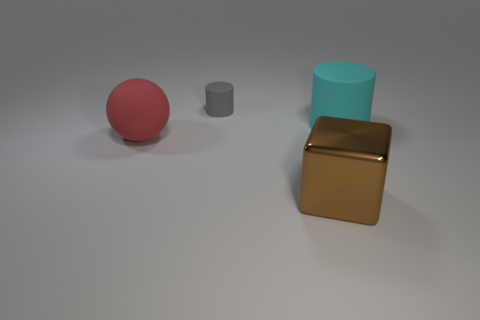Is there anything else that is the same material as the gray object?
Provide a short and direct response. Yes. What number of matte things are there?
Keep it short and to the point. 3. Does the tiny cylinder have the same color as the big metal thing?
Your answer should be very brief. No. There is a thing that is on the right side of the large red object and to the left of the large brown shiny thing; what color is it?
Keep it short and to the point. Gray. There is a tiny gray matte cylinder; are there any brown metal objects behind it?
Your answer should be very brief. No. What number of big cyan cylinders are behind the big rubber thing that is right of the tiny gray cylinder?
Give a very brief answer. 0. There is a sphere that is the same material as the cyan thing; what size is it?
Your answer should be very brief. Large. How big is the block?
Provide a short and direct response. Large. Are the cyan thing and the large cube made of the same material?
Provide a short and direct response. No. How many blocks are either small rubber things or metal objects?
Your answer should be very brief. 1. 